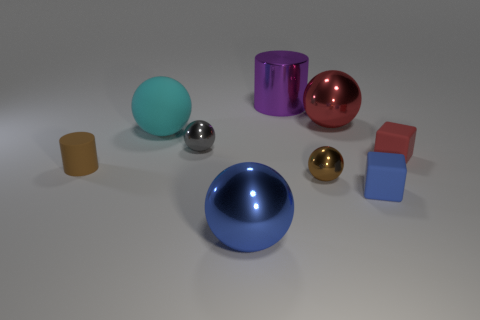Subtract all shiny balls. How many balls are left? 1 Subtract all cyan spheres. How many spheres are left? 4 Add 1 tiny red shiny cylinders. How many objects exist? 10 Subtract 4 spheres. How many spheres are left? 1 Subtract all blocks. How many objects are left? 7 Subtract all cyan cylinders. How many gray spheres are left? 1 Add 9 matte cylinders. How many matte cylinders are left? 10 Add 4 cylinders. How many cylinders exist? 6 Subtract 1 cyan spheres. How many objects are left? 8 Subtract all purple cylinders. Subtract all red cubes. How many cylinders are left? 1 